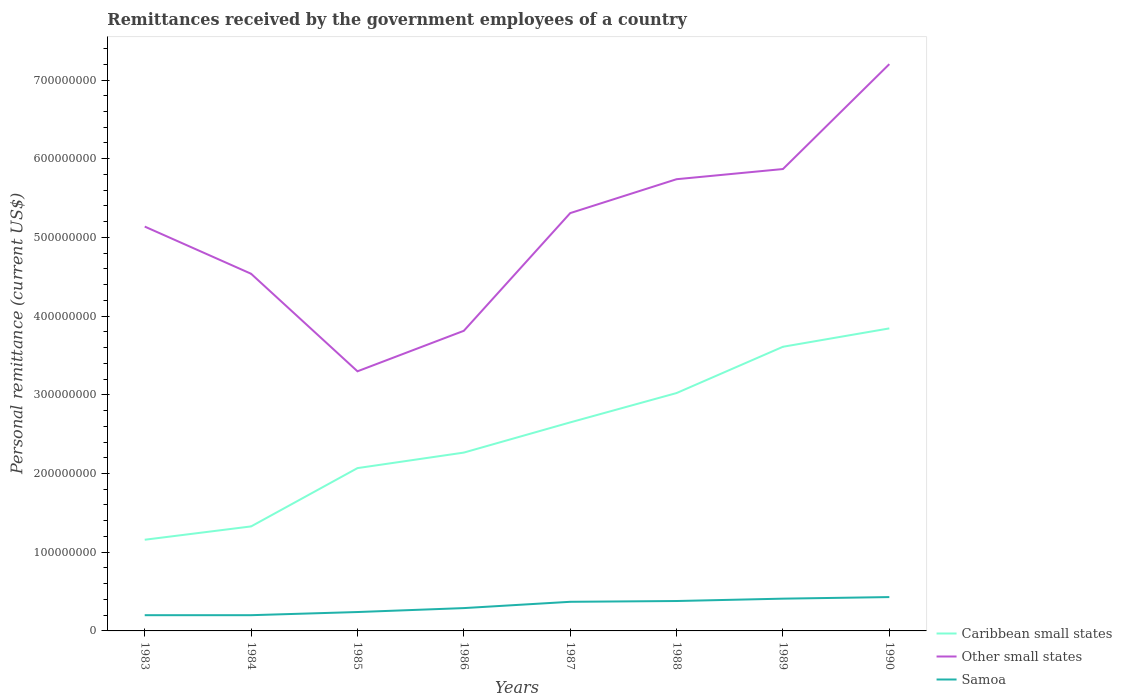Does the line corresponding to Other small states intersect with the line corresponding to Samoa?
Offer a terse response. No. Across all years, what is the maximum remittances received by the government employees in Caribbean small states?
Give a very brief answer. 1.16e+08. What is the difference between the highest and the second highest remittances received by the government employees in Caribbean small states?
Provide a succinct answer. 2.69e+08. What is the difference between the highest and the lowest remittances received by the government employees in Samoa?
Provide a short and direct response. 4. How many lines are there?
Your response must be concise. 3. Are the values on the major ticks of Y-axis written in scientific E-notation?
Keep it short and to the point. No. Does the graph contain any zero values?
Provide a short and direct response. No. How many legend labels are there?
Provide a short and direct response. 3. How are the legend labels stacked?
Make the answer very short. Vertical. What is the title of the graph?
Your response must be concise. Remittances received by the government employees of a country. Does "East Asia (developing only)" appear as one of the legend labels in the graph?
Provide a short and direct response. No. What is the label or title of the X-axis?
Give a very brief answer. Years. What is the label or title of the Y-axis?
Your response must be concise. Personal remittance (current US$). What is the Personal remittance (current US$) of Caribbean small states in 1983?
Give a very brief answer. 1.16e+08. What is the Personal remittance (current US$) in Other small states in 1983?
Your response must be concise. 5.14e+08. What is the Personal remittance (current US$) of Caribbean small states in 1984?
Offer a very short reply. 1.33e+08. What is the Personal remittance (current US$) of Other small states in 1984?
Make the answer very short. 4.54e+08. What is the Personal remittance (current US$) of Caribbean small states in 1985?
Offer a terse response. 2.07e+08. What is the Personal remittance (current US$) of Other small states in 1985?
Offer a terse response. 3.30e+08. What is the Personal remittance (current US$) of Samoa in 1985?
Keep it short and to the point. 2.40e+07. What is the Personal remittance (current US$) in Caribbean small states in 1986?
Ensure brevity in your answer.  2.27e+08. What is the Personal remittance (current US$) in Other small states in 1986?
Offer a terse response. 3.81e+08. What is the Personal remittance (current US$) of Samoa in 1986?
Give a very brief answer. 2.90e+07. What is the Personal remittance (current US$) in Caribbean small states in 1987?
Offer a very short reply. 2.65e+08. What is the Personal remittance (current US$) in Other small states in 1987?
Your answer should be very brief. 5.31e+08. What is the Personal remittance (current US$) in Samoa in 1987?
Your response must be concise. 3.70e+07. What is the Personal remittance (current US$) in Caribbean small states in 1988?
Your answer should be very brief. 3.02e+08. What is the Personal remittance (current US$) of Other small states in 1988?
Your response must be concise. 5.74e+08. What is the Personal remittance (current US$) in Samoa in 1988?
Offer a very short reply. 3.80e+07. What is the Personal remittance (current US$) in Caribbean small states in 1989?
Make the answer very short. 3.61e+08. What is the Personal remittance (current US$) of Other small states in 1989?
Keep it short and to the point. 5.87e+08. What is the Personal remittance (current US$) of Samoa in 1989?
Offer a terse response. 4.10e+07. What is the Personal remittance (current US$) of Caribbean small states in 1990?
Give a very brief answer. 3.84e+08. What is the Personal remittance (current US$) in Other small states in 1990?
Provide a succinct answer. 7.20e+08. What is the Personal remittance (current US$) of Samoa in 1990?
Give a very brief answer. 4.30e+07. Across all years, what is the maximum Personal remittance (current US$) in Caribbean small states?
Make the answer very short. 3.84e+08. Across all years, what is the maximum Personal remittance (current US$) in Other small states?
Give a very brief answer. 7.20e+08. Across all years, what is the maximum Personal remittance (current US$) in Samoa?
Provide a short and direct response. 4.30e+07. Across all years, what is the minimum Personal remittance (current US$) in Caribbean small states?
Give a very brief answer. 1.16e+08. Across all years, what is the minimum Personal remittance (current US$) of Other small states?
Make the answer very short. 3.30e+08. What is the total Personal remittance (current US$) of Caribbean small states in the graph?
Your answer should be very brief. 1.99e+09. What is the total Personal remittance (current US$) of Other small states in the graph?
Offer a very short reply. 4.09e+09. What is the total Personal remittance (current US$) of Samoa in the graph?
Ensure brevity in your answer.  2.52e+08. What is the difference between the Personal remittance (current US$) of Caribbean small states in 1983 and that in 1984?
Offer a terse response. -1.69e+07. What is the difference between the Personal remittance (current US$) in Other small states in 1983 and that in 1984?
Make the answer very short. 6.00e+07. What is the difference between the Personal remittance (current US$) in Samoa in 1983 and that in 1984?
Offer a very short reply. 0. What is the difference between the Personal remittance (current US$) in Caribbean small states in 1983 and that in 1985?
Your response must be concise. -9.10e+07. What is the difference between the Personal remittance (current US$) of Other small states in 1983 and that in 1985?
Provide a short and direct response. 1.84e+08. What is the difference between the Personal remittance (current US$) in Samoa in 1983 and that in 1985?
Your response must be concise. -4.00e+06. What is the difference between the Personal remittance (current US$) of Caribbean small states in 1983 and that in 1986?
Offer a terse response. -1.11e+08. What is the difference between the Personal remittance (current US$) in Other small states in 1983 and that in 1986?
Offer a very short reply. 1.32e+08. What is the difference between the Personal remittance (current US$) in Samoa in 1983 and that in 1986?
Give a very brief answer. -9.00e+06. What is the difference between the Personal remittance (current US$) of Caribbean small states in 1983 and that in 1987?
Make the answer very short. -1.49e+08. What is the difference between the Personal remittance (current US$) in Other small states in 1983 and that in 1987?
Offer a terse response. -1.71e+07. What is the difference between the Personal remittance (current US$) of Samoa in 1983 and that in 1987?
Offer a very short reply. -1.70e+07. What is the difference between the Personal remittance (current US$) in Caribbean small states in 1983 and that in 1988?
Ensure brevity in your answer.  -1.86e+08. What is the difference between the Personal remittance (current US$) in Other small states in 1983 and that in 1988?
Your answer should be very brief. -6.02e+07. What is the difference between the Personal remittance (current US$) of Samoa in 1983 and that in 1988?
Provide a short and direct response. -1.80e+07. What is the difference between the Personal remittance (current US$) of Caribbean small states in 1983 and that in 1989?
Ensure brevity in your answer.  -2.45e+08. What is the difference between the Personal remittance (current US$) of Other small states in 1983 and that in 1989?
Your answer should be compact. -7.31e+07. What is the difference between the Personal remittance (current US$) of Samoa in 1983 and that in 1989?
Give a very brief answer. -2.10e+07. What is the difference between the Personal remittance (current US$) of Caribbean small states in 1983 and that in 1990?
Provide a succinct answer. -2.69e+08. What is the difference between the Personal remittance (current US$) in Other small states in 1983 and that in 1990?
Offer a very short reply. -2.06e+08. What is the difference between the Personal remittance (current US$) of Samoa in 1983 and that in 1990?
Make the answer very short. -2.30e+07. What is the difference between the Personal remittance (current US$) of Caribbean small states in 1984 and that in 1985?
Your response must be concise. -7.41e+07. What is the difference between the Personal remittance (current US$) of Other small states in 1984 and that in 1985?
Your response must be concise. 1.24e+08. What is the difference between the Personal remittance (current US$) in Samoa in 1984 and that in 1985?
Provide a short and direct response. -4.00e+06. What is the difference between the Personal remittance (current US$) in Caribbean small states in 1984 and that in 1986?
Provide a short and direct response. -9.38e+07. What is the difference between the Personal remittance (current US$) of Other small states in 1984 and that in 1986?
Keep it short and to the point. 7.25e+07. What is the difference between the Personal remittance (current US$) of Samoa in 1984 and that in 1986?
Provide a short and direct response. -9.00e+06. What is the difference between the Personal remittance (current US$) in Caribbean small states in 1984 and that in 1987?
Ensure brevity in your answer.  -1.32e+08. What is the difference between the Personal remittance (current US$) of Other small states in 1984 and that in 1987?
Ensure brevity in your answer.  -7.71e+07. What is the difference between the Personal remittance (current US$) of Samoa in 1984 and that in 1987?
Provide a succinct answer. -1.70e+07. What is the difference between the Personal remittance (current US$) of Caribbean small states in 1984 and that in 1988?
Ensure brevity in your answer.  -1.69e+08. What is the difference between the Personal remittance (current US$) of Other small states in 1984 and that in 1988?
Provide a succinct answer. -1.20e+08. What is the difference between the Personal remittance (current US$) in Samoa in 1984 and that in 1988?
Provide a succinct answer. -1.80e+07. What is the difference between the Personal remittance (current US$) in Caribbean small states in 1984 and that in 1989?
Ensure brevity in your answer.  -2.28e+08. What is the difference between the Personal remittance (current US$) in Other small states in 1984 and that in 1989?
Provide a short and direct response. -1.33e+08. What is the difference between the Personal remittance (current US$) in Samoa in 1984 and that in 1989?
Offer a terse response. -2.10e+07. What is the difference between the Personal remittance (current US$) in Caribbean small states in 1984 and that in 1990?
Your response must be concise. -2.52e+08. What is the difference between the Personal remittance (current US$) in Other small states in 1984 and that in 1990?
Offer a terse response. -2.66e+08. What is the difference between the Personal remittance (current US$) of Samoa in 1984 and that in 1990?
Provide a succinct answer. -2.30e+07. What is the difference between the Personal remittance (current US$) in Caribbean small states in 1985 and that in 1986?
Offer a terse response. -1.97e+07. What is the difference between the Personal remittance (current US$) of Other small states in 1985 and that in 1986?
Your answer should be compact. -5.15e+07. What is the difference between the Personal remittance (current US$) of Samoa in 1985 and that in 1986?
Keep it short and to the point. -5.00e+06. What is the difference between the Personal remittance (current US$) in Caribbean small states in 1985 and that in 1987?
Your answer should be very brief. -5.81e+07. What is the difference between the Personal remittance (current US$) of Other small states in 1985 and that in 1987?
Provide a short and direct response. -2.01e+08. What is the difference between the Personal remittance (current US$) in Samoa in 1985 and that in 1987?
Your answer should be very brief. -1.30e+07. What is the difference between the Personal remittance (current US$) of Caribbean small states in 1985 and that in 1988?
Offer a terse response. -9.54e+07. What is the difference between the Personal remittance (current US$) in Other small states in 1985 and that in 1988?
Offer a very short reply. -2.44e+08. What is the difference between the Personal remittance (current US$) in Samoa in 1985 and that in 1988?
Offer a very short reply. -1.40e+07. What is the difference between the Personal remittance (current US$) in Caribbean small states in 1985 and that in 1989?
Provide a succinct answer. -1.54e+08. What is the difference between the Personal remittance (current US$) in Other small states in 1985 and that in 1989?
Your answer should be compact. -2.57e+08. What is the difference between the Personal remittance (current US$) of Samoa in 1985 and that in 1989?
Keep it short and to the point. -1.70e+07. What is the difference between the Personal remittance (current US$) of Caribbean small states in 1985 and that in 1990?
Offer a very short reply. -1.78e+08. What is the difference between the Personal remittance (current US$) in Other small states in 1985 and that in 1990?
Keep it short and to the point. -3.90e+08. What is the difference between the Personal remittance (current US$) in Samoa in 1985 and that in 1990?
Provide a succinct answer. -1.90e+07. What is the difference between the Personal remittance (current US$) in Caribbean small states in 1986 and that in 1987?
Ensure brevity in your answer.  -3.84e+07. What is the difference between the Personal remittance (current US$) of Other small states in 1986 and that in 1987?
Provide a succinct answer. -1.50e+08. What is the difference between the Personal remittance (current US$) of Samoa in 1986 and that in 1987?
Provide a succinct answer. -8.00e+06. What is the difference between the Personal remittance (current US$) in Caribbean small states in 1986 and that in 1988?
Offer a terse response. -7.57e+07. What is the difference between the Personal remittance (current US$) of Other small states in 1986 and that in 1988?
Provide a short and direct response. -1.93e+08. What is the difference between the Personal remittance (current US$) of Samoa in 1986 and that in 1988?
Ensure brevity in your answer.  -9.00e+06. What is the difference between the Personal remittance (current US$) in Caribbean small states in 1986 and that in 1989?
Offer a terse response. -1.34e+08. What is the difference between the Personal remittance (current US$) in Other small states in 1986 and that in 1989?
Offer a very short reply. -2.06e+08. What is the difference between the Personal remittance (current US$) in Samoa in 1986 and that in 1989?
Provide a short and direct response. -1.20e+07. What is the difference between the Personal remittance (current US$) in Caribbean small states in 1986 and that in 1990?
Ensure brevity in your answer.  -1.58e+08. What is the difference between the Personal remittance (current US$) of Other small states in 1986 and that in 1990?
Provide a succinct answer. -3.39e+08. What is the difference between the Personal remittance (current US$) in Samoa in 1986 and that in 1990?
Provide a short and direct response. -1.40e+07. What is the difference between the Personal remittance (current US$) of Caribbean small states in 1987 and that in 1988?
Your response must be concise. -3.73e+07. What is the difference between the Personal remittance (current US$) in Other small states in 1987 and that in 1988?
Offer a very short reply. -4.31e+07. What is the difference between the Personal remittance (current US$) of Samoa in 1987 and that in 1988?
Offer a terse response. -1.00e+06. What is the difference between the Personal remittance (current US$) in Caribbean small states in 1987 and that in 1989?
Provide a succinct answer. -9.61e+07. What is the difference between the Personal remittance (current US$) in Other small states in 1987 and that in 1989?
Make the answer very short. -5.60e+07. What is the difference between the Personal remittance (current US$) of Caribbean small states in 1987 and that in 1990?
Make the answer very short. -1.19e+08. What is the difference between the Personal remittance (current US$) of Other small states in 1987 and that in 1990?
Provide a short and direct response. -1.89e+08. What is the difference between the Personal remittance (current US$) in Samoa in 1987 and that in 1990?
Provide a short and direct response. -6.00e+06. What is the difference between the Personal remittance (current US$) in Caribbean small states in 1988 and that in 1989?
Your answer should be very brief. -5.88e+07. What is the difference between the Personal remittance (current US$) in Other small states in 1988 and that in 1989?
Keep it short and to the point. -1.29e+07. What is the difference between the Personal remittance (current US$) in Caribbean small states in 1988 and that in 1990?
Your response must be concise. -8.21e+07. What is the difference between the Personal remittance (current US$) in Other small states in 1988 and that in 1990?
Offer a terse response. -1.46e+08. What is the difference between the Personal remittance (current US$) of Samoa in 1988 and that in 1990?
Your answer should be compact. -5.00e+06. What is the difference between the Personal remittance (current US$) in Caribbean small states in 1989 and that in 1990?
Your answer should be very brief. -2.33e+07. What is the difference between the Personal remittance (current US$) of Other small states in 1989 and that in 1990?
Your answer should be very brief. -1.33e+08. What is the difference between the Personal remittance (current US$) of Caribbean small states in 1983 and the Personal remittance (current US$) of Other small states in 1984?
Offer a very short reply. -3.38e+08. What is the difference between the Personal remittance (current US$) in Caribbean small states in 1983 and the Personal remittance (current US$) in Samoa in 1984?
Ensure brevity in your answer.  9.58e+07. What is the difference between the Personal remittance (current US$) of Other small states in 1983 and the Personal remittance (current US$) of Samoa in 1984?
Your response must be concise. 4.94e+08. What is the difference between the Personal remittance (current US$) in Caribbean small states in 1983 and the Personal remittance (current US$) in Other small states in 1985?
Give a very brief answer. -2.14e+08. What is the difference between the Personal remittance (current US$) in Caribbean small states in 1983 and the Personal remittance (current US$) in Samoa in 1985?
Make the answer very short. 9.18e+07. What is the difference between the Personal remittance (current US$) of Other small states in 1983 and the Personal remittance (current US$) of Samoa in 1985?
Keep it short and to the point. 4.90e+08. What is the difference between the Personal remittance (current US$) of Caribbean small states in 1983 and the Personal remittance (current US$) of Other small states in 1986?
Make the answer very short. -2.66e+08. What is the difference between the Personal remittance (current US$) of Caribbean small states in 1983 and the Personal remittance (current US$) of Samoa in 1986?
Your answer should be very brief. 8.68e+07. What is the difference between the Personal remittance (current US$) in Other small states in 1983 and the Personal remittance (current US$) in Samoa in 1986?
Your answer should be very brief. 4.85e+08. What is the difference between the Personal remittance (current US$) in Caribbean small states in 1983 and the Personal remittance (current US$) in Other small states in 1987?
Give a very brief answer. -4.15e+08. What is the difference between the Personal remittance (current US$) in Caribbean small states in 1983 and the Personal remittance (current US$) in Samoa in 1987?
Give a very brief answer. 7.88e+07. What is the difference between the Personal remittance (current US$) in Other small states in 1983 and the Personal remittance (current US$) in Samoa in 1987?
Make the answer very short. 4.77e+08. What is the difference between the Personal remittance (current US$) of Caribbean small states in 1983 and the Personal remittance (current US$) of Other small states in 1988?
Your answer should be very brief. -4.58e+08. What is the difference between the Personal remittance (current US$) in Caribbean small states in 1983 and the Personal remittance (current US$) in Samoa in 1988?
Provide a short and direct response. 7.78e+07. What is the difference between the Personal remittance (current US$) in Other small states in 1983 and the Personal remittance (current US$) in Samoa in 1988?
Keep it short and to the point. 4.76e+08. What is the difference between the Personal remittance (current US$) of Caribbean small states in 1983 and the Personal remittance (current US$) of Other small states in 1989?
Ensure brevity in your answer.  -4.71e+08. What is the difference between the Personal remittance (current US$) in Caribbean small states in 1983 and the Personal remittance (current US$) in Samoa in 1989?
Your response must be concise. 7.48e+07. What is the difference between the Personal remittance (current US$) of Other small states in 1983 and the Personal remittance (current US$) of Samoa in 1989?
Your answer should be compact. 4.73e+08. What is the difference between the Personal remittance (current US$) in Caribbean small states in 1983 and the Personal remittance (current US$) in Other small states in 1990?
Keep it short and to the point. -6.04e+08. What is the difference between the Personal remittance (current US$) of Caribbean small states in 1983 and the Personal remittance (current US$) of Samoa in 1990?
Make the answer very short. 7.28e+07. What is the difference between the Personal remittance (current US$) of Other small states in 1983 and the Personal remittance (current US$) of Samoa in 1990?
Provide a short and direct response. 4.71e+08. What is the difference between the Personal remittance (current US$) of Caribbean small states in 1984 and the Personal remittance (current US$) of Other small states in 1985?
Make the answer very short. -1.97e+08. What is the difference between the Personal remittance (current US$) of Caribbean small states in 1984 and the Personal remittance (current US$) of Samoa in 1985?
Give a very brief answer. 1.09e+08. What is the difference between the Personal remittance (current US$) of Other small states in 1984 and the Personal remittance (current US$) of Samoa in 1985?
Offer a terse response. 4.30e+08. What is the difference between the Personal remittance (current US$) of Caribbean small states in 1984 and the Personal remittance (current US$) of Other small states in 1986?
Keep it short and to the point. -2.49e+08. What is the difference between the Personal remittance (current US$) in Caribbean small states in 1984 and the Personal remittance (current US$) in Samoa in 1986?
Make the answer very short. 1.04e+08. What is the difference between the Personal remittance (current US$) of Other small states in 1984 and the Personal remittance (current US$) of Samoa in 1986?
Provide a succinct answer. 4.25e+08. What is the difference between the Personal remittance (current US$) in Caribbean small states in 1984 and the Personal remittance (current US$) in Other small states in 1987?
Make the answer very short. -3.98e+08. What is the difference between the Personal remittance (current US$) in Caribbean small states in 1984 and the Personal remittance (current US$) in Samoa in 1987?
Provide a short and direct response. 9.58e+07. What is the difference between the Personal remittance (current US$) of Other small states in 1984 and the Personal remittance (current US$) of Samoa in 1987?
Give a very brief answer. 4.17e+08. What is the difference between the Personal remittance (current US$) of Caribbean small states in 1984 and the Personal remittance (current US$) of Other small states in 1988?
Offer a terse response. -4.41e+08. What is the difference between the Personal remittance (current US$) of Caribbean small states in 1984 and the Personal remittance (current US$) of Samoa in 1988?
Your response must be concise. 9.48e+07. What is the difference between the Personal remittance (current US$) in Other small states in 1984 and the Personal remittance (current US$) in Samoa in 1988?
Provide a short and direct response. 4.16e+08. What is the difference between the Personal remittance (current US$) of Caribbean small states in 1984 and the Personal remittance (current US$) of Other small states in 1989?
Provide a short and direct response. -4.54e+08. What is the difference between the Personal remittance (current US$) of Caribbean small states in 1984 and the Personal remittance (current US$) of Samoa in 1989?
Give a very brief answer. 9.18e+07. What is the difference between the Personal remittance (current US$) of Other small states in 1984 and the Personal remittance (current US$) of Samoa in 1989?
Ensure brevity in your answer.  4.13e+08. What is the difference between the Personal remittance (current US$) in Caribbean small states in 1984 and the Personal remittance (current US$) in Other small states in 1990?
Offer a very short reply. -5.87e+08. What is the difference between the Personal remittance (current US$) in Caribbean small states in 1984 and the Personal remittance (current US$) in Samoa in 1990?
Provide a short and direct response. 8.98e+07. What is the difference between the Personal remittance (current US$) in Other small states in 1984 and the Personal remittance (current US$) in Samoa in 1990?
Keep it short and to the point. 4.11e+08. What is the difference between the Personal remittance (current US$) in Caribbean small states in 1985 and the Personal remittance (current US$) in Other small states in 1986?
Your response must be concise. -1.74e+08. What is the difference between the Personal remittance (current US$) in Caribbean small states in 1985 and the Personal remittance (current US$) in Samoa in 1986?
Give a very brief answer. 1.78e+08. What is the difference between the Personal remittance (current US$) of Other small states in 1985 and the Personal remittance (current US$) of Samoa in 1986?
Your answer should be compact. 3.01e+08. What is the difference between the Personal remittance (current US$) of Caribbean small states in 1985 and the Personal remittance (current US$) of Other small states in 1987?
Provide a short and direct response. -3.24e+08. What is the difference between the Personal remittance (current US$) in Caribbean small states in 1985 and the Personal remittance (current US$) in Samoa in 1987?
Make the answer very short. 1.70e+08. What is the difference between the Personal remittance (current US$) of Other small states in 1985 and the Personal remittance (current US$) of Samoa in 1987?
Your answer should be compact. 2.93e+08. What is the difference between the Personal remittance (current US$) in Caribbean small states in 1985 and the Personal remittance (current US$) in Other small states in 1988?
Ensure brevity in your answer.  -3.67e+08. What is the difference between the Personal remittance (current US$) of Caribbean small states in 1985 and the Personal remittance (current US$) of Samoa in 1988?
Give a very brief answer. 1.69e+08. What is the difference between the Personal remittance (current US$) of Other small states in 1985 and the Personal remittance (current US$) of Samoa in 1988?
Make the answer very short. 2.92e+08. What is the difference between the Personal remittance (current US$) in Caribbean small states in 1985 and the Personal remittance (current US$) in Other small states in 1989?
Your answer should be very brief. -3.80e+08. What is the difference between the Personal remittance (current US$) in Caribbean small states in 1985 and the Personal remittance (current US$) in Samoa in 1989?
Ensure brevity in your answer.  1.66e+08. What is the difference between the Personal remittance (current US$) in Other small states in 1985 and the Personal remittance (current US$) in Samoa in 1989?
Your response must be concise. 2.89e+08. What is the difference between the Personal remittance (current US$) of Caribbean small states in 1985 and the Personal remittance (current US$) of Other small states in 1990?
Keep it short and to the point. -5.13e+08. What is the difference between the Personal remittance (current US$) of Caribbean small states in 1985 and the Personal remittance (current US$) of Samoa in 1990?
Offer a very short reply. 1.64e+08. What is the difference between the Personal remittance (current US$) in Other small states in 1985 and the Personal remittance (current US$) in Samoa in 1990?
Your answer should be compact. 2.87e+08. What is the difference between the Personal remittance (current US$) in Caribbean small states in 1986 and the Personal remittance (current US$) in Other small states in 1987?
Give a very brief answer. -3.04e+08. What is the difference between the Personal remittance (current US$) in Caribbean small states in 1986 and the Personal remittance (current US$) in Samoa in 1987?
Keep it short and to the point. 1.90e+08. What is the difference between the Personal remittance (current US$) of Other small states in 1986 and the Personal remittance (current US$) of Samoa in 1987?
Offer a terse response. 3.44e+08. What is the difference between the Personal remittance (current US$) of Caribbean small states in 1986 and the Personal remittance (current US$) of Other small states in 1988?
Your answer should be compact. -3.47e+08. What is the difference between the Personal remittance (current US$) in Caribbean small states in 1986 and the Personal remittance (current US$) in Samoa in 1988?
Offer a terse response. 1.89e+08. What is the difference between the Personal remittance (current US$) of Other small states in 1986 and the Personal remittance (current US$) of Samoa in 1988?
Keep it short and to the point. 3.43e+08. What is the difference between the Personal remittance (current US$) of Caribbean small states in 1986 and the Personal remittance (current US$) of Other small states in 1989?
Ensure brevity in your answer.  -3.60e+08. What is the difference between the Personal remittance (current US$) in Caribbean small states in 1986 and the Personal remittance (current US$) in Samoa in 1989?
Offer a terse response. 1.86e+08. What is the difference between the Personal remittance (current US$) in Other small states in 1986 and the Personal remittance (current US$) in Samoa in 1989?
Provide a short and direct response. 3.40e+08. What is the difference between the Personal remittance (current US$) of Caribbean small states in 1986 and the Personal remittance (current US$) of Other small states in 1990?
Make the answer very short. -4.94e+08. What is the difference between the Personal remittance (current US$) in Caribbean small states in 1986 and the Personal remittance (current US$) in Samoa in 1990?
Give a very brief answer. 1.84e+08. What is the difference between the Personal remittance (current US$) in Other small states in 1986 and the Personal remittance (current US$) in Samoa in 1990?
Your answer should be very brief. 3.38e+08. What is the difference between the Personal remittance (current US$) of Caribbean small states in 1987 and the Personal remittance (current US$) of Other small states in 1988?
Provide a succinct answer. -3.09e+08. What is the difference between the Personal remittance (current US$) in Caribbean small states in 1987 and the Personal remittance (current US$) in Samoa in 1988?
Offer a terse response. 2.27e+08. What is the difference between the Personal remittance (current US$) of Other small states in 1987 and the Personal remittance (current US$) of Samoa in 1988?
Provide a short and direct response. 4.93e+08. What is the difference between the Personal remittance (current US$) of Caribbean small states in 1987 and the Personal remittance (current US$) of Other small states in 1989?
Your answer should be very brief. -3.22e+08. What is the difference between the Personal remittance (current US$) in Caribbean small states in 1987 and the Personal remittance (current US$) in Samoa in 1989?
Ensure brevity in your answer.  2.24e+08. What is the difference between the Personal remittance (current US$) of Other small states in 1987 and the Personal remittance (current US$) of Samoa in 1989?
Keep it short and to the point. 4.90e+08. What is the difference between the Personal remittance (current US$) of Caribbean small states in 1987 and the Personal remittance (current US$) of Other small states in 1990?
Make the answer very short. -4.55e+08. What is the difference between the Personal remittance (current US$) in Caribbean small states in 1987 and the Personal remittance (current US$) in Samoa in 1990?
Offer a terse response. 2.22e+08. What is the difference between the Personal remittance (current US$) in Other small states in 1987 and the Personal remittance (current US$) in Samoa in 1990?
Your answer should be very brief. 4.88e+08. What is the difference between the Personal remittance (current US$) in Caribbean small states in 1988 and the Personal remittance (current US$) in Other small states in 1989?
Your answer should be compact. -2.85e+08. What is the difference between the Personal remittance (current US$) in Caribbean small states in 1988 and the Personal remittance (current US$) in Samoa in 1989?
Offer a terse response. 2.61e+08. What is the difference between the Personal remittance (current US$) in Other small states in 1988 and the Personal remittance (current US$) in Samoa in 1989?
Provide a succinct answer. 5.33e+08. What is the difference between the Personal remittance (current US$) in Caribbean small states in 1988 and the Personal remittance (current US$) in Other small states in 1990?
Your answer should be compact. -4.18e+08. What is the difference between the Personal remittance (current US$) in Caribbean small states in 1988 and the Personal remittance (current US$) in Samoa in 1990?
Your answer should be compact. 2.59e+08. What is the difference between the Personal remittance (current US$) in Other small states in 1988 and the Personal remittance (current US$) in Samoa in 1990?
Your response must be concise. 5.31e+08. What is the difference between the Personal remittance (current US$) of Caribbean small states in 1989 and the Personal remittance (current US$) of Other small states in 1990?
Provide a succinct answer. -3.59e+08. What is the difference between the Personal remittance (current US$) of Caribbean small states in 1989 and the Personal remittance (current US$) of Samoa in 1990?
Your answer should be very brief. 3.18e+08. What is the difference between the Personal remittance (current US$) in Other small states in 1989 and the Personal remittance (current US$) in Samoa in 1990?
Give a very brief answer. 5.44e+08. What is the average Personal remittance (current US$) of Caribbean small states per year?
Your answer should be very brief. 2.49e+08. What is the average Personal remittance (current US$) of Other small states per year?
Offer a very short reply. 5.11e+08. What is the average Personal remittance (current US$) in Samoa per year?
Your answer should be very brief. 3.15e+07. In the year 1983, what is the difference between the Personal remittance (current US$) in Caribbean small states and Personal remittance (current US$) in Other small states?
Provide a short and direct response. -3.98e+08. In the year 1983, what is the difference between the Personal remittance (current US$) of Caribbean small states and Personal remittance (current US$) of Samoa?
Your response must be concise. 9.58e+07. In the year 1983, what is the difference between the Personal remittance (current US$) in Other small states and Personal remittance (current US$) in Samoa?
Keep it short and to the point. 4.94e+08. In the year 1984, what is the difference between the Personal remittance (current US$) of Caribbean small states and Personal remittance (current US$) of Other small states?
Your answer should be compact. -3.21e+08. In the year 1984, what is the difference between the Personal remittance (current US$) of Caribbean small states and Personal remittance (current US$) of Samoa?
Offer a very short reply. 1.13e+08. In the year 1984, what is the difference between the Personal remittance (current US$) in Other small states and Personal remittance (current US$) in Samoa?
Provide a short and direct response. 4.34e+08. In the year 1985, what is the difference between the Personal remittance (current US$) of Caribbean small states and Personal remittance (current US$) of Other small states?
Provide a short and direct response. -1.23e+08. In the year 1985, what is the difference between the Personal remittance (current US$) of Caribbean small states and Personal remittance (current US$) of Samoa?
Make the answer very short. 1.83e+08. In the year 1985, what is the difference between the Personal remittance (current US$) of Other small states and Personal remittance (current US$) of Samoa?
Make the answer very short. 3.06e+08. In the year 1986, what is the difference between the Personal remittance (current US$) in Caribbean small states and Personal remittance (current US$) in Other small states?
Give a very brief answer. -1.55e+08. In the year 1986, what is the difference between the Personal remittance (current US$) of Caribbean small states and Personal remittance (current US$) of Samoa?
Make the answer very short. 1.98e+08. In the year 1986, what is the difference between the Personal remittance (current US$) in Other small states and Personal remittance (current US$) in Samoa?
Keep it short and to the point. 3.52e+08. In the year 1987, what is the difference between the Personal remittance (current US$) in Caribbean small states and Personal remittance (current US$) in Other small states?
Give a very brief answer. -2.66e+08. In the year 1987, what is the difference between the Personal remittance (current US$) in Caribbean small states and Personal remittance (current US$) in Samoa?
Your answer should be very brief. 2.28e+08. In the year 1987, what is the difference between the Personal remittance (current US$) in Other small states and Personal remittance (current US$) in Samoa?
Make the answer very short. 4.94e+08. In the year 1988, what is the difference between the Personal remittance (current US$) in Caribbean small states and Personal remittance (current US$) in Other small states?
Make the answer very short. -2.72e+08. In the year 1988, what is the difference between the Personal remittance (current US$) in Caribbean small states and Personal remittance (current US$) in Samoa?
Your answer should be very brief. 2.64e+08. In the year 1988, what is the difference between the Personal remittance (current US$) of Other small states and Personal remittance (current US$) of Samoa?
Your answer should be compact. 5.36e+08. In the year 1989, what is the difference between the Personal remittance (current US$) of Caribbean small states and Personal remittance (current US$) of Other small states?
Your answer should be compact. -2.26e+08. In the year 1989, what is the difference between the Personal remittance (current US$) of Caribbean small states and Personal remittance (current US$) of Samoa?
Offer a very short reply. 3.20e+08. In the year 1989, what is the difference between the Personal remittance (current US$) in Other small states and Personal remittance (current US$) in Samoa?
Offer a very short reply. 5.46e+08. In the year 1990, what is the difference between the Personal remittance (current US$) in Caribbean small states and Personal remittance (current US$) in Other small states?
Your answer should be compact. -3.36e+08. In the year 1990, what is the difference between the Personal remittance (current US$) of Caribbean small states and Personal remittance (current US$) of Samoa?
Offer a very short reply. 3.41e+08. In the year 1990, what is the difference between the Personal remittance (current US$) of Other small states and Personal remittance (current US$) of Samoa?
Your answer should be compact. 6.77e+08. What is the ratio of the Personal remittance (current US$) of Caribbean small states in 1983 to that in 1984?
Provide a short and direct response. 0.87. What is the ratio of the Personal remittance (current US$) of Other small states in 1983 to that in 1984?
Make the answer very short. 1.13. What is the ratio of the Personal remittance (current US$) of Samoa in 1983 to that in 1984?
Make the answer very short. 1. What is the ratio of the Personal remittance (current US$) of Caribbean small states in 1983 to that in 1985?
Ensure brevity in your answer.  0.56. What is the ratio of the Personal remittance (current US$) in Other small states in 1983 to that in 1985?
Offer a terse response. 1.56. What is the ratio of the Personal remittance (current US$) in Samoa in 1983 to that in 1985?
Keep it short and to the point. 0.83. What is the ratio of the Personal remittance (current US$) of Caribbean small states in 1983 to that in 1986?
Ensure brevity in your answer.  0.51. What is the ratio of the Personal remittance (current US$) of Other small states in 1983 to that in 1986?
Your response must be concise. 1.35. What is the ratio of the Personal remittance (current US$) of Samoa in 1983 to that in 1986?
Offer a terse response. 0.69. What is the ratio of the Personal remittance (current US$) of Caribbean small states in 1983 to that in 1987?
Ensure brevity in your answer.  0.44. What is the ratio of the Personal remittance (current US$) of Other small states in 1983 to that in 1987?
Give a very brief answer. 0.97. What is the ratio of the Personal remittance (current US$) in Samoa in 1983 to that in 1987?
Provide a succinct answer. 0.54. What is the ratio of the Personal remittance (current US$) of Caribbean small states in 1983 to that in 1988?
Your response must be concise. 0.38. What is the ratio of the Personal remittance (current US$) in Other small states in 1983 to that in 1988?
Your response must be concise. 0.9. What is the ratio of the Personal remittance (current US$) of Samoa in 1983 to that in 1988?
Your answer should be compact. 0.53. What is the ratio of the Personal remittance (current US$) of Caribbean small states in 1983 to that in 1989?
Offer a terse response. 0.32. What is the ratio of the Personal remittance (current US$) of Other small states in 1983 to that in 1989?
Offer a very short reply. 0.88. What is the ratio of the Personal remittance (current US$) of Samoa in 1983 to that in 1989?
Ensure brevity in your answer.  0.49. What is the ratio of the Personal remittance (current US$) in Caribbean small states in 1983 to that in 1990?
Ensure brevity in your answer.  0.3. What is the ratio of the Personal remittance (current US$) of Other small states in 1983 to that in 1990?
Make the answer very short. 0.71. What is the ratio of the Personal remittance (current US$) in Samoa in 1983 to that in 1990?
Ensure brevity in your answer.  0.47. What is the ratio of the Personal remittance (current US$) in Caribbean small states in 1984 to that in 1985?
Your answer should be very brief. 0.64. What is the ratio of the Personal remittance (current US$) in Other small states in 1984 to that in 1985?
Make the answer very short. 1.38. What is the ratio of the Personal remittance (current US$) of Caribbean small states in 1984 to that in 1986?
Your answer should be compact. 0.59. What is the ratio of the Personal remittance (current US$) in Other small states in 1984 to that in 1986?
Offer a terse response. 1.19. What is the ratio of the Personal remittance (current US$) of Samoa in 1984 to that in 1986?
Give a very brief answer. 0.69. What is the ratio of the Personal remittance (current US$) of Caribbean small states in 1984 to that in 1987?
Your answer should be very brief. 0.5. What is the ratio of the Personal remittance (current US$) of Other small states in 1984 to that in 1987?
Make the answer very short. 0.85. What is the ratio of the Personal remittance (current US$) in Samoa in 1984 to that in 1987?
Your answer should be very brief. 0.54. What is the ratio of the Personal remittance (current US$) in Caribbean small states in 1984 to that in 1988?
Provide a short and direct response. 0.44. What is the ratio of the Personal remittance (current US$) of Other small states in 1984 to that in 1988?
Provide a succinct answer. 0.79. What is the ratio of the Personal remittance (current US$) of Samoa in 1984 to that in 1988?
Offer a terse response. 0.53. What is the ratio of the Personal remittance (current US$) of Caribbean small states in 1984 to that in 1989?
Your answer should be very brief. 0.37. What is the ratio of the Personal remittance (current US$) of Other small states in 1984 to that in 1989?
Ensure brevity in your answer.  0.77. What is the ratio of the Personal remittance (current US$) of Samoa in 1984 to that in 1989?
Make the answer very short. 0.49. What is the ratio of the Personal remittance (current US$) in Caribbean small states in 1984 to that in 1990?
Offer a terse response. 0.35. What is the ratio of the Personal remittance (current US$) in Other small states in 1984 to that in 1990?
Your answer should be compact. 0.63. What is the ratio of the Personal remittance (current US$) in Samoa in 1984 to that in 1990?
Ensure brevity in your answer.  0.47. What is the ratio of the Personal remittance (current US$) in Caribbean small states in 1985 to that in 1986?
Your answer should be very brief. 0.91. What is the ratio of the Personal remittance (current US$) of Other small states in 1985 to that in 1986?
Make the answer very short. 0.87. What is the ratio of the Personal remittance (current US$) of Samoa in 1985 to that in 1986?
Ensure brevity in your answer.  0.83. What is the ratio of the Personal remittance (current US$) in Caribbean small states in 1985 to that in 1987?
Offer a terse response. 0.78. What is the ratio of the Personal remittance (current US$) of Other small states in 1985 to that in 1987?
Your response must be concise. 0.62. What is the ratio of the Personal remittance (current US$) of Samoa in 1985 to that in 1987?
Your answer should be compact. 0.65. What is the ratio of the Personal remittance (current US$) of Caribbean small states in 1985 to that in 1988?
Keep it short and to the point. 0.68. What is the ratio of the Personal remittance (current US$) in Other small states in 1985 to that in 1988?
Give a very brief answer. 0.57. What is the ratio of the Personal remittance (current US$) of Samoa in 1985 to that in 1988?
Your answer should be compact. 0.63. What is the ratio of the Personal remittance (current US$) of Caribbean small states in 1985 to that in 1989?
Your answer should be compact. 0.57. What is the ratio of the Personal remittance (current US$) in Other small states in 1985 to that in 1989?
Ensure brevity in your answer.  0.56. What is the ratio of the Personal remittance (current US$) of Samoa in 1985 to that in 1989?
Ensure brevity in your answer.  0.59. What is the ratio of the Personal remittance (current US$) in Caribbean small states in 1985 to that in 1990?
Offer a very short reply. 0.54. What is the ratio of the Personal remittance (current US$) in Other small states in 1985 to that in 1990?
Give a very brief answer. 0.46. What is the ratio of the Personal remittance (current US$) of Samoa in 1985 to that in 1990?
Give a very brief answer. 0.56. What is the ratio of the Personal remittance (current US$) of Caribbean small states in 1986 to that in 1987?
Ensure brevity in your answer.  0.86. What is the ratio of the Personal remittance (current US$) in Other small states in 1986 to that in 1987?
Keep it short and to the point. 0.72. What is the ratio of the Personal remittance (current US$) in Samoa in 1986 to that in 1987?
Provide a short and direct response. 0.78. What is the ratio of the Personal remittance (current US$) in Caribbean small states in 1986 to that in 1988?
Your response must be concise. 0.75. What is the ratio of the Personal remittance (current US$) in Other small states in 1986 to that in 1988?
Offer a very short reply. 0.66. What is the ratio of the Personal remittance (current US$) in Samoa in 1986 to that in 1988?
Offer a terse response. 0.76. What is the ratio of the Personal remittance (current US$) in Caribbean small states in 1986 to that in 1989?
Provide a succinct answer. 0.63. What is the ratio of the Personal remittance (current US$) of Other small states in 1986 to that in 1989?
Make the answer very short. 0.65. What is the ratio of the Personal remittance (current US$) of Samoa in 1986 to that in 1989?
Provide a short and direct response. 0.71. What is the ratio of the Personal remittance (current US$) in Caribbean small states in 1986 to that in 1990?
Your response must be concise. 0.59. What is the ratio of the Personal remittance (current US$) of Other small states in 1986 to that in 1990?
Your answer should be compact. 0.53. What is the ratio of the Personal remittance (current US$) of Samoa in 1986 to that in 1990?
Offer a very short reply. 0.67. What is the ratio of the Personal remittance (current US$) in Caribbean small states in 1987 to that in 1988?
Provide a short and direct response. 0.88. What is the ratio of the Personal remittance (current US$) in Other small states in 1987 to that in 1988?
Provide a succinct answer. 0.93. What is the ratio of the Personal remittance (current US$) in Samoa in 1987 to that in 1988?
Make the answer very short. 0.97. What is the ratio of the Personal remittance (current US$) in Caribbean small states in 1987 to that in 1989?
Offer a very short reply. 0.73. What is the ratio of the Personal remittance (current US$) of Other small states in 1987 to that in 1989?
Your answer should be very brief. 0.9. What is the ratio of the Personal remittance (current US$) in Samoa in 1987 to that in 1989?
Provide a short and direct response. 0.9. What is the ratio of the Personal remittance (current US$) of Caribbean small states in 1987 to that in 1990?
Your response must be concise. 0.69. What is the ratio of the Personal remittance (current US$) of Other small states in 1987 to that in 1990?
Offer a terse response. 0.74. What is the ratio of the Personal remittance (current US$) of Samoa in 1987 to that in 1990?
Provide a short and direct response. 0.86. What is the ratio of the Personal remittance (current US$) of Caribbean small states in 1988 to that in 1989?
Keep it short and to the point. 0.84. What is the ratio of the Personal remittance (current US$) of Other small states in 1988 to that in 1989?
Offer a very short reply. 0.98. What is the ratio of the Personal remittance (current US$) in Samoa in 1988 to that in 1989?
Your answer should be very brief. 0.93. What is the ratio of the Personal remittance (current US$) in Caribbean small states in 1988 to that in 1990?
Give a very brief answer. 0.79. What is the ratio of the Personal remittance (current US$) in Other small states in 1988 to that in 1990?
Keep it short and to the point. 0.8. What is the ratio of the Personal remittance (current US$) in Samoa in 1988 to that in 1990?
Offer a very short reply. 0.88. What is the ratio of the Personal remittance (current US$) of Caribbean small states in 1989 to that in 1990?
Your response must be concise. 0.94. What is the ratio of the Personal remittance (current US$) in Other small states in 1989 to that in 1990?
Your response must be concise. 0.81. What is the ratio of the Personal remittance (current US$) of Samoa in 1989 to that in 1990?
Offer a very short reply. 0.95. What is the difference between the highest and the second highest Personal remittance (current US$) in Caribbean small states?
Offer a very short reply. 2.33e+07. What is the difference between the highest and the second highest Personal remittance (current US$) of Other small states?
Give a very brief answer. 1.33e+08. What is the difference between the highest and the second highest Personal remittance (current US$) of Samoa?
Provide a short and direct response. 2.00e+06. What is the difference between the highest and the lowest Personal remittance (current US$) of Caribbean small states?
Your answer should be compact. 2.69e+08. What is the difference between the highest and the lowest Personal remittance (current US$) of Other small states?
Give a very brief answer. 3.90e+08. What is the difference between the highest and the lowest Personal remittance (current US$) of Samoa?
Keep it short and to the point. 2.30e+07. 